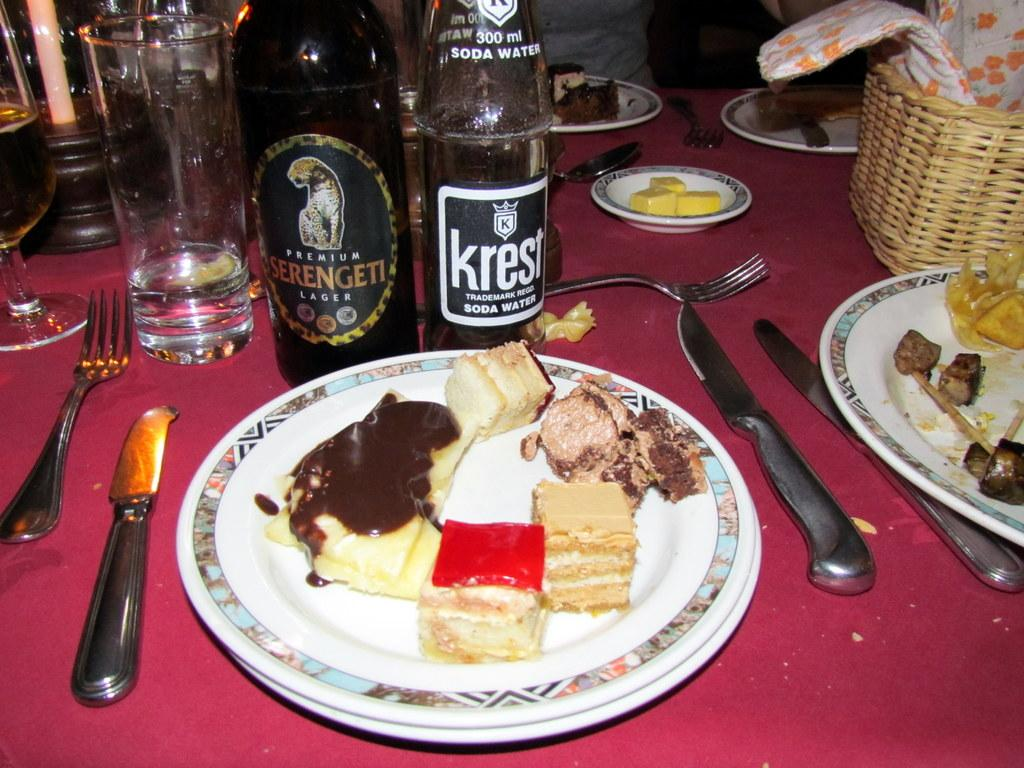<image>
Present a compact description of the photo's key features. Bottle that says KREST in front of a plate of food. 